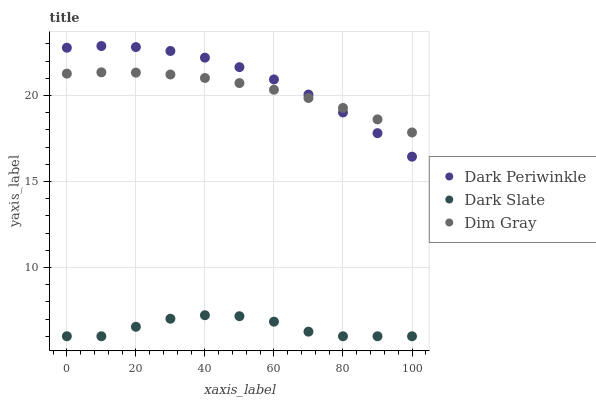Does Dark Slate have the minimum area under the curve?
Answer yes or no. Yes. Does Dark Periwinkle have the maximum area under the curve?
Answer yes or no. Yes. Does Dim Gray have the minimum area under the curve?
Answer yes or no. No. Does Dim Gray have the maximum area under the curve?
Answer yes or no. No. Is Dim Gray the smoothest?
Answer yes or no. Yes. Is Dark Slate the roughest?
Answer yes or no. Yes. Is Dark Periwinkle the smoothest?
Answer yes or no. No. Is Dark Periwinkle the roughest?
Answer yes or no. No. Does Dark Slate have the lowest value?
Answer yes or no. Yes. Does Dark Periwinkle have the lowest value?
Answer yes or no. No. Does Dark Periwinkle have the highest value?
Answer yes or no. Yes. Does Dim Gray have the highest value?
Answer yes or no. No. Is Dark Slate less than Dim Gray?
Answer yes or no. Yes. Is Dark Periwinkle greater than Dark Slate?
Answer yes or no. Yes. Does Dim Gray intersect Dark Periwinkle?
Answer yes or no. Yes. Is Dim Gray less than Dark Periwinkle?
Answer yes or no. No. Is Dim Gray greater than Dark Periwinkle?
Answer yes or no. No. Does Dark Slate intersect Dim Gray?
Answer yes or no. No. 